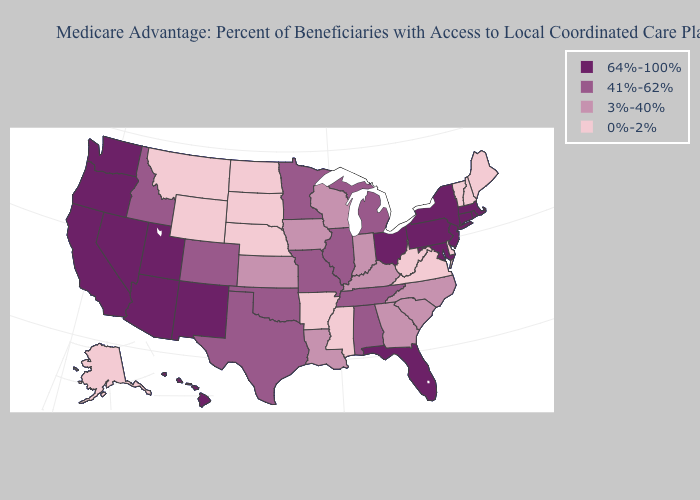Does Iowa have the lowest value in the MidWest?
Quick response, please. No. Does the first symbol in the legend represent the smallest category?
Be succinct. No. Name the states that have a value in the range 41%-62%?
Quick response, please. Alabama, Colorado, Idaho, Illinois, Michigan, Minnesota, Missouri, Oklahoma, Tennessee, Texas. Name the states that have a value in the range 41%-62%?
Concise answer only. Alabama, Colorado, Idaho, Illinois, Michigan, Minnesota, Missouri, Oklahoma, Tennessee, Texas. Name the states that have a value in the range 3%-40%?
Quick response, please. Georgia, Iowa, Indiana, Kansas, Kentucky, Louisiana, North Carolina, South Carolina, Wisconsin. Does Montana have the highest value in the West?
Short answer required. No. What is the value of New York?
Answer briefly. 64%-100%. Does Utah have the same value as Wisconsin?
Short answer required. No. Which states hav the highest value in the Northeast?
Short answer required. Connecticut, Massachusetts, New Jersey, New York, Pennsylvania, Rhode Island. What is the highest value in states that border Texas?
Quick response, please. 64%-100%. What is the value of Alaska?
Write a very short answer. 0%-2%. Among the states that border California , which have the highest value?
Short answer required. Arizona, Nevada, Oregon. Does North Carolina have a lower value than New York?
Quick response, please. Yes. Does Maryland have the same value as Georgia?
Give a very brief answer. No. 